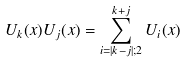Convert formula to latex. <formula><loc_0><loc_0><loc_500><loc_500>U _ { k } ( x ) U _ { j } ( x ) = \sum _ { i = | k - j | ; 2 } ^ { k + j } U _ { i } ( x ) \</formula> 